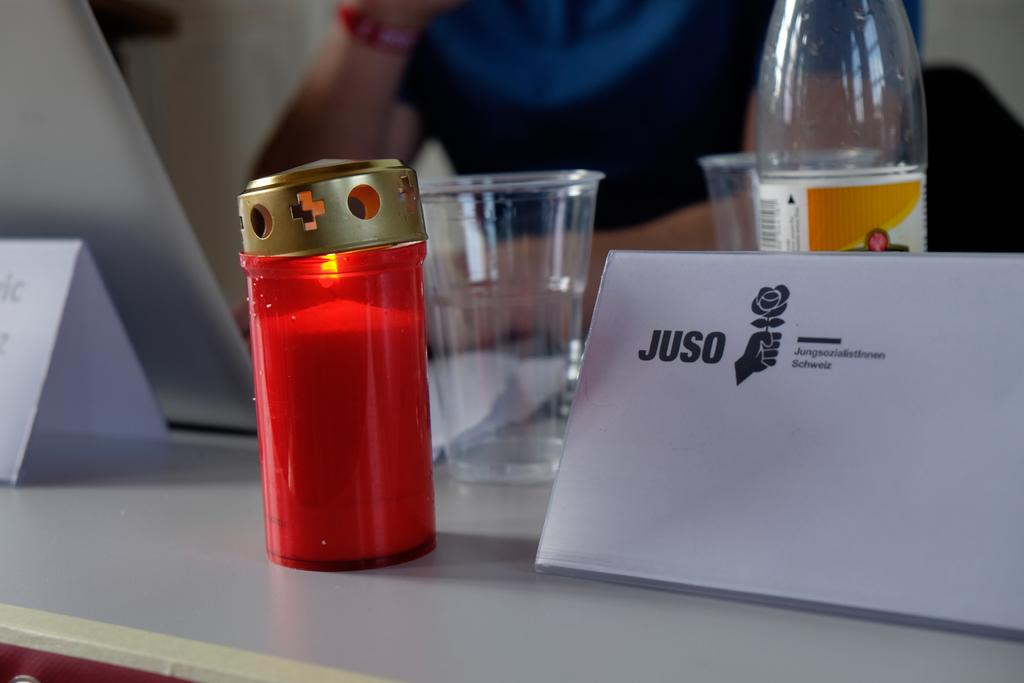What objects in the image are used for labeling or identification? There are name boards in the image. What type of containers are present in the image? There are disposable tumblers and a disposal bottle in the image. What is the source of light in the image? There is a candle in a candle holder in the image. What type of pencil is being used to write on the name boards in the image? There is no pencil visible in the image; the name boards are likely labeled using other methods. Are there any mittens present in the image? No, there are no mittens present in the image. 